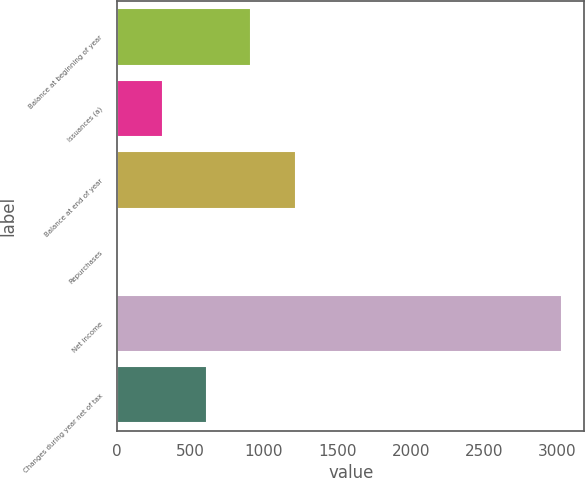<chart> <loc_0><loc_0><loc_500><loc_500><bar_chart><fcel>Balance at beginning of year<fcel>Issuances (a)<fcel>Balance at end of year<fcel>Repurchases<fcel>Net income<fcel>Changes during year net of tax<nl><fcel>914.5<fcel>309.5<fcel>1217<fcel>7<fcel>3032<fcel>612<nl></chart> 